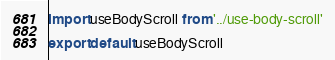Convert code to text. <code><loc_0><loc_0><loc_500><loc_500><_TypeScript_>import useBodyScroll from '../use-body-scroll'

export default useBodyScroll
</code> 